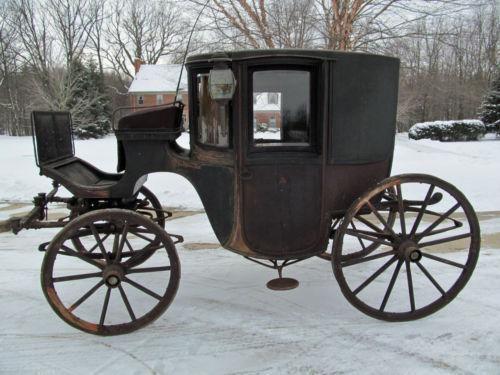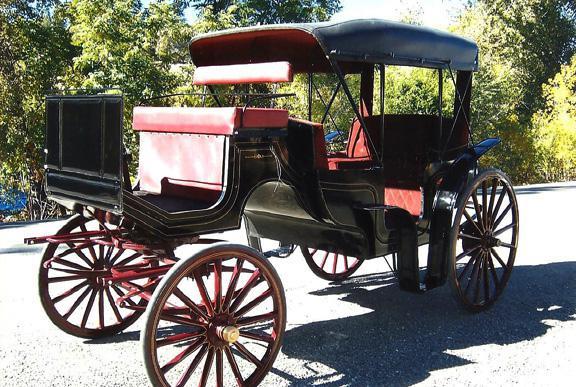The first image is the image on the left, the second image is the image on the right. Given the left and right images, does the statement "An image shows a buggy with treaded rubber tires." hold true? Answer yes or no. No. 